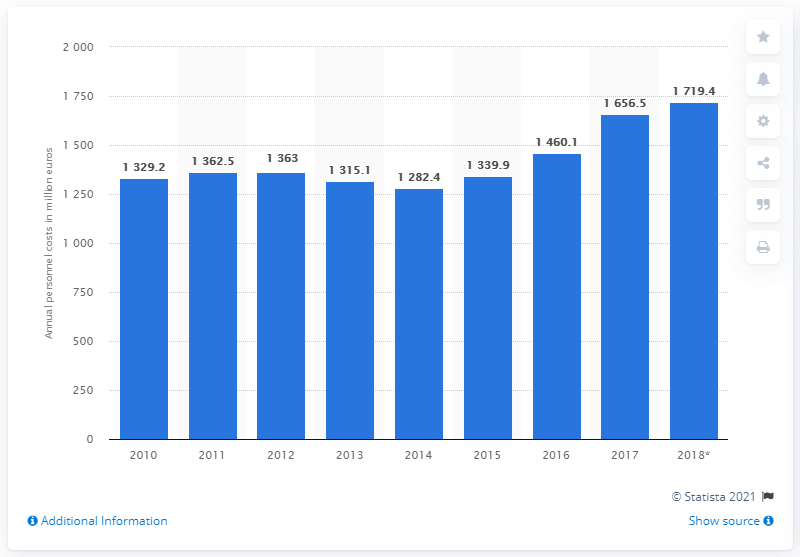Outline some significant characteristics in this image. The annual personnel costs of the Danish construction industry in 2018 were approximately 1719.4 million Danish kroner. In 2016, the personnel costs for the Danish construction industry totaled 1,460.1 million Danish kroner. 